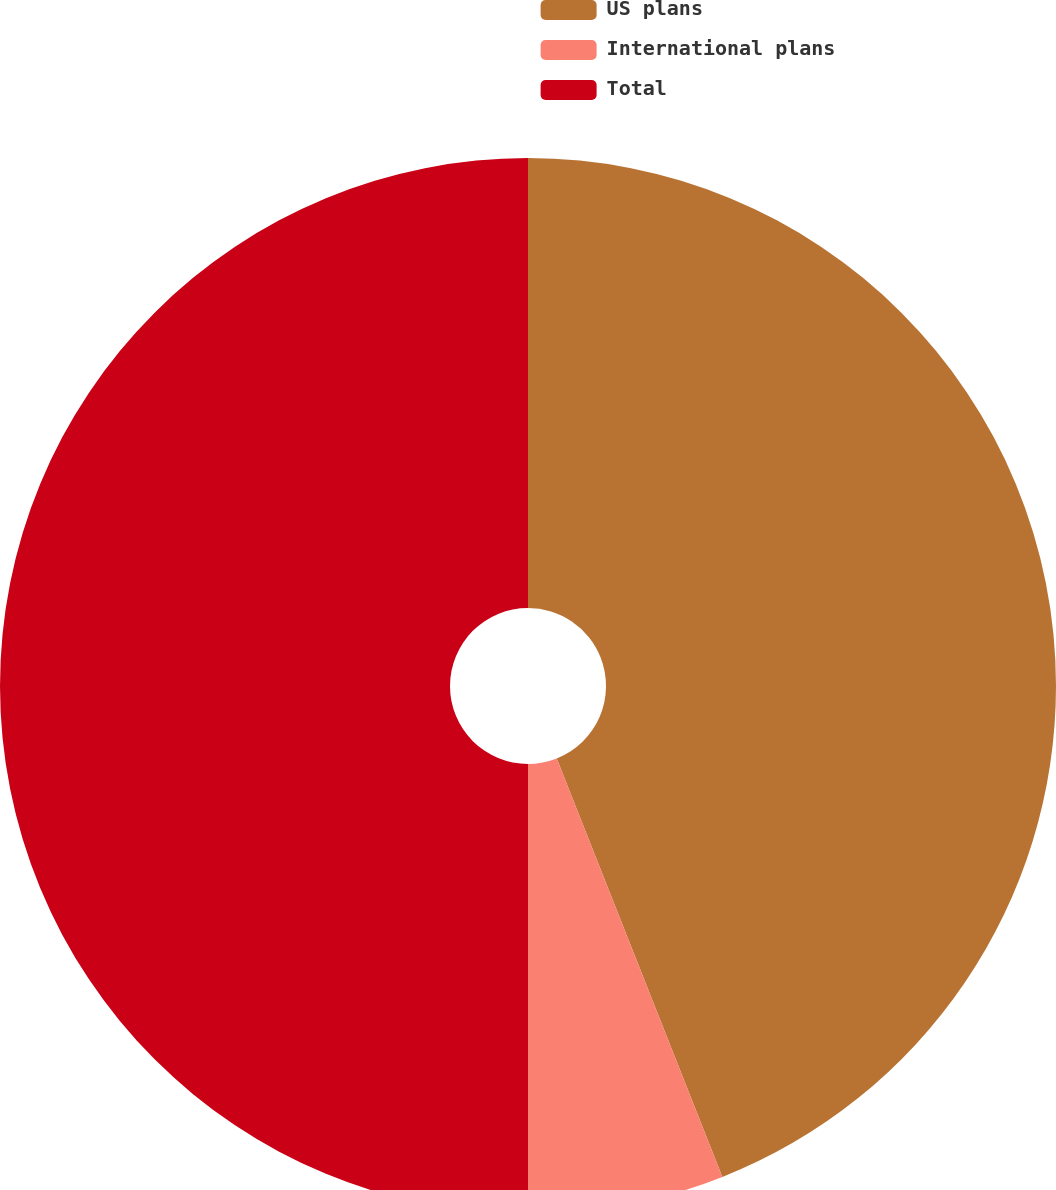<chart> <loc_0><loc_0><loc_500><loc_500><pie_chart><fcel>US plans<fcel>International plans<fcel>Total<nl><fcel>44.0%<fcel>6.0%<fcel>50.0%<nl></chart> 